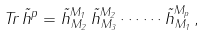<formula> <loc_0><loc_0><loc_500><loc_500>T r \, \tilde { h } ^ { p } = \tilde { h } ^ { M _ { 1 } } _ { \, M _ { 2 } } \, \tilde { h } ^ { M _ { 2 } } _ { \, M _ { 3 } } \cdots \cdots \tilde { h } ^ { M _ { p } } _ { \, M _ { 1 } } \, ,</formula> 